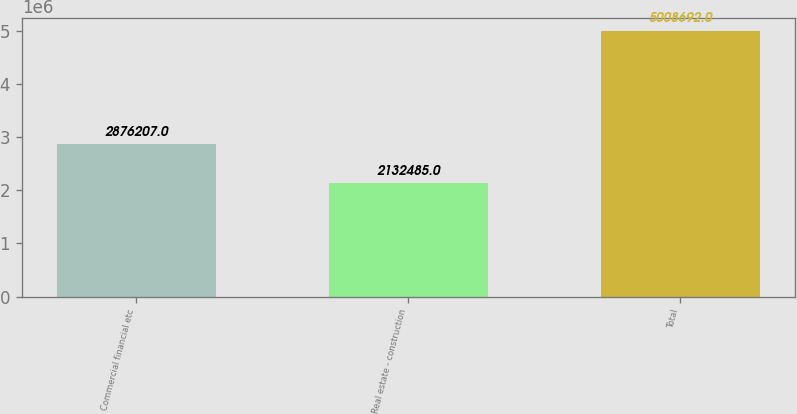Convert chart. <chart><loc_0><loc_0><loc_500><loc_500><bar_chart><fcel>Commercial financial etc<fcel>Real estate - construction<fcel>Total<nl><fcel>2.87621e+06<fcel>2.13248e+06<fcel>5.00869e+06<nl></chart> 